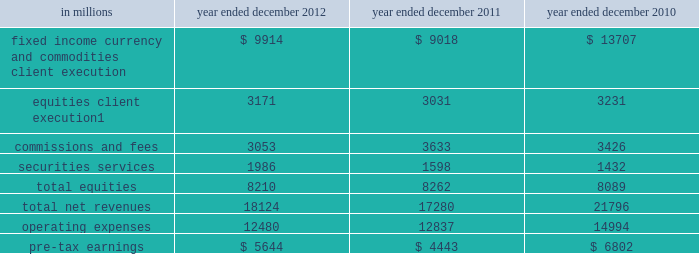Management 2019s discussion and analysis the table below presents the operating results of our institutional client services segment. .
Includes net revenues related to reinsurance of $ 1.08 billion , $ 880 million and $ 827 million for the years ended december 2012 , december 2011 and december 2010 , respectively .
2012 versus 2011 .
Net revenues in institutional client services were $ 18.12 billion for 2012 , 5% ( 5 % ) higher than 2011 .
Net revenues in fixed income , currency and commodities client execution were $ 9.91 billion for 2012 , 10% ( 10 % ) higher than 2011 .
These results reflected strong net revenues in mortgages , which were significantly higher compared with 2011 .
In addition , net revenues in credit products and interest rate products were solid and higher compared with 2011 .
These increases were partially offset by significantly lower net revenues in commodities and slightly lower net revenues in currencies .
Although broad market concerns persisted during 2012 , fixed income , currency and commodities client execution operated in a generally improved environment characterized by tighter credit spreads and less challenging market-making conditions compared with 2011 .
Net revenues in equities were $ 8.21 billion for 2012 , essentially unchanged compared with 2011 .
Net revenues in securities services were significantly higher compared with 2011 , reflecting a gain of approximately $ 500 million on the sale of our hedge fund administration business .
In addition , equities client execution net revenues were higher than 2011 , primarily reflecting significantly higher results in cash products , principally due to increased levels of client activity .
These increases were offset by lower commissions and fees , reflecting lower market volumes .
During 2012 , equities operated in an environment generally characterized by an increase in global equity prices and lower volatility levels .
The net loss attributable to the impact of changes in our own credit spreads on borrowings for which the fair value option was elected was $ 714 million ( $ 433 million and $ 281 million related to fixed income , currency and commodities client execution and equities client execution , respectively ) for 2012 , compared with a net gain of $ 596 million ( $ 399 million and $ 197 million related to fixed income , currency and commodities client execution and equities client execution , respectively ) for 2011 .
During 2012 , institutional client services operated in an environment generally characterized by continued broad market concerns and uncertainties , although positive developments helped to improve market conditions .
These developments included certain central bank actions to ease monetary policy and address funding risks for european financial institutions .
In addition , the u.s .
Economy posted stable to improving economic data , including favorable developments in unemployment and housing .
These improvements resulted in tighter credit spreads , higher global equity prices and lower levels of volatility .
However , concerns about the outlook for the global economy and continued political uncertainty , particularly the political debate in the united states surrounding the fiscal cliff , generally resulted in client risk aversion and lower activity levels .
Also , uncertainty over financial regulatory reform persisted .
If these concerns and uncertainties continue over the long term , net revenues in fixed income , currency and commodities client execution and equities would likely be negatively impacted .
Operating expenses were $ 12.48 billion for 2012 , 3% ( 3 % ) lower than 2011 , primarily due to lower brokerage , clearing , exchange and distribution fees , and lower impairment charges , partially offset by higher net provisions for litigation and regulatory proceedings .
Pre-tax earnings were $ 5.64 billion in 2012 , 27% ( 27 % ) higher than 2011 .
2011 versus 2010 .
Net revenues in institutional client services were $ 17.28 billion for 2011 , 21% ( 21 % ) lower than 2010 .
Net revenues in fixed income , currency and commodities client execution were $ 9.02 billion for 2011 , 34% ( 34 % ) lower than 2010 .
Although activity levels during 2011 were generally consistent with 2010 levels , and results were solid during the first quarter of 2011 , the environment during the remainder of 2011 was characterized by broad market concerns and uncertainty , resulting in volatile markets and significantly wider credit spreads , which contributed to difficult market-making conditions and led to reductions in risk by us and our clients .
As a result of these conditions , net revenues across the franchise were lower , including significant declines in mortgages and credit products , compared with 2010 .
54 goldman sachs 2012 annual report .
What is the growth rate in net revenues in 2011? 
Computations: ((17280 - 21796) / 21796)
Answer: -0.20719. 